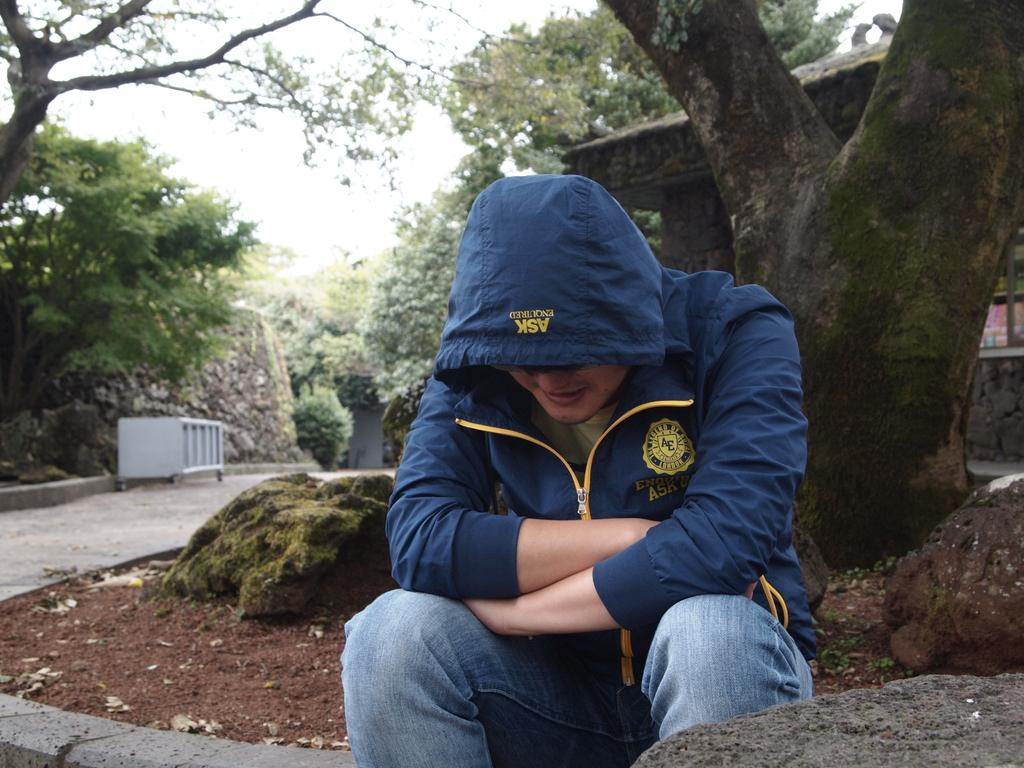Who or what is present in the image? There is a person in the image. What is the person doing in the image? The person is seated. What can be seen near the person in the image? There are rocks beside the person. What is visible in the background of the image? There are trees and a house in the background of the image. What type of jam is the person eating in the image? There is no jam present in the image, and the person is not eating anything. 